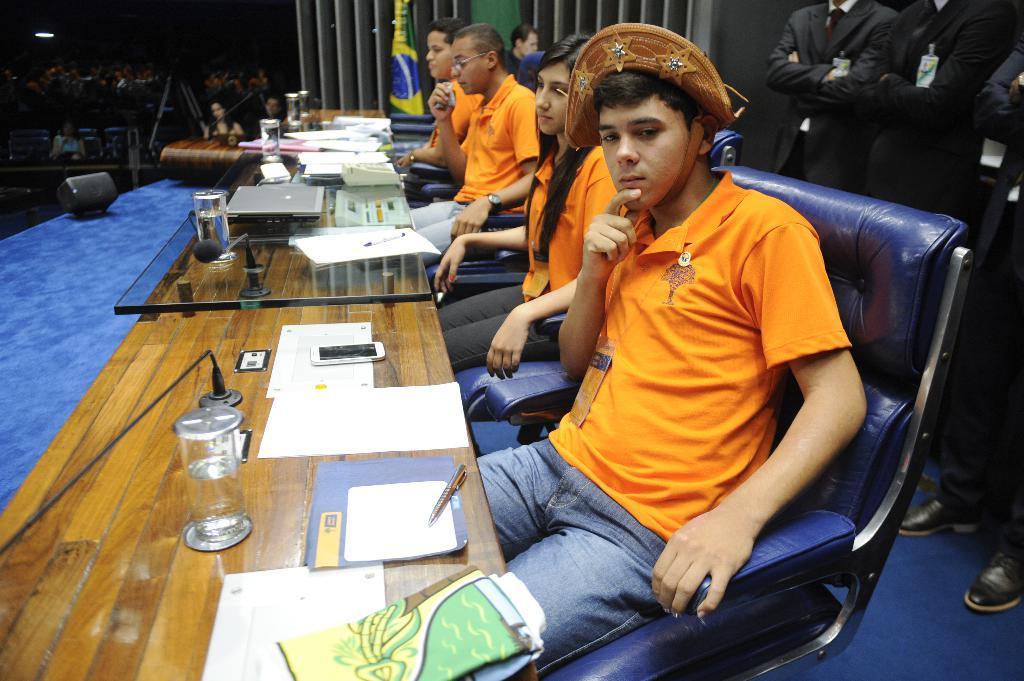In one or two sentences, can you explain what this image depicts? The persons wearing orange shirts are sitting in a chair and there is a table in front of them which has some objects on it and there are some persons standing behind them. 